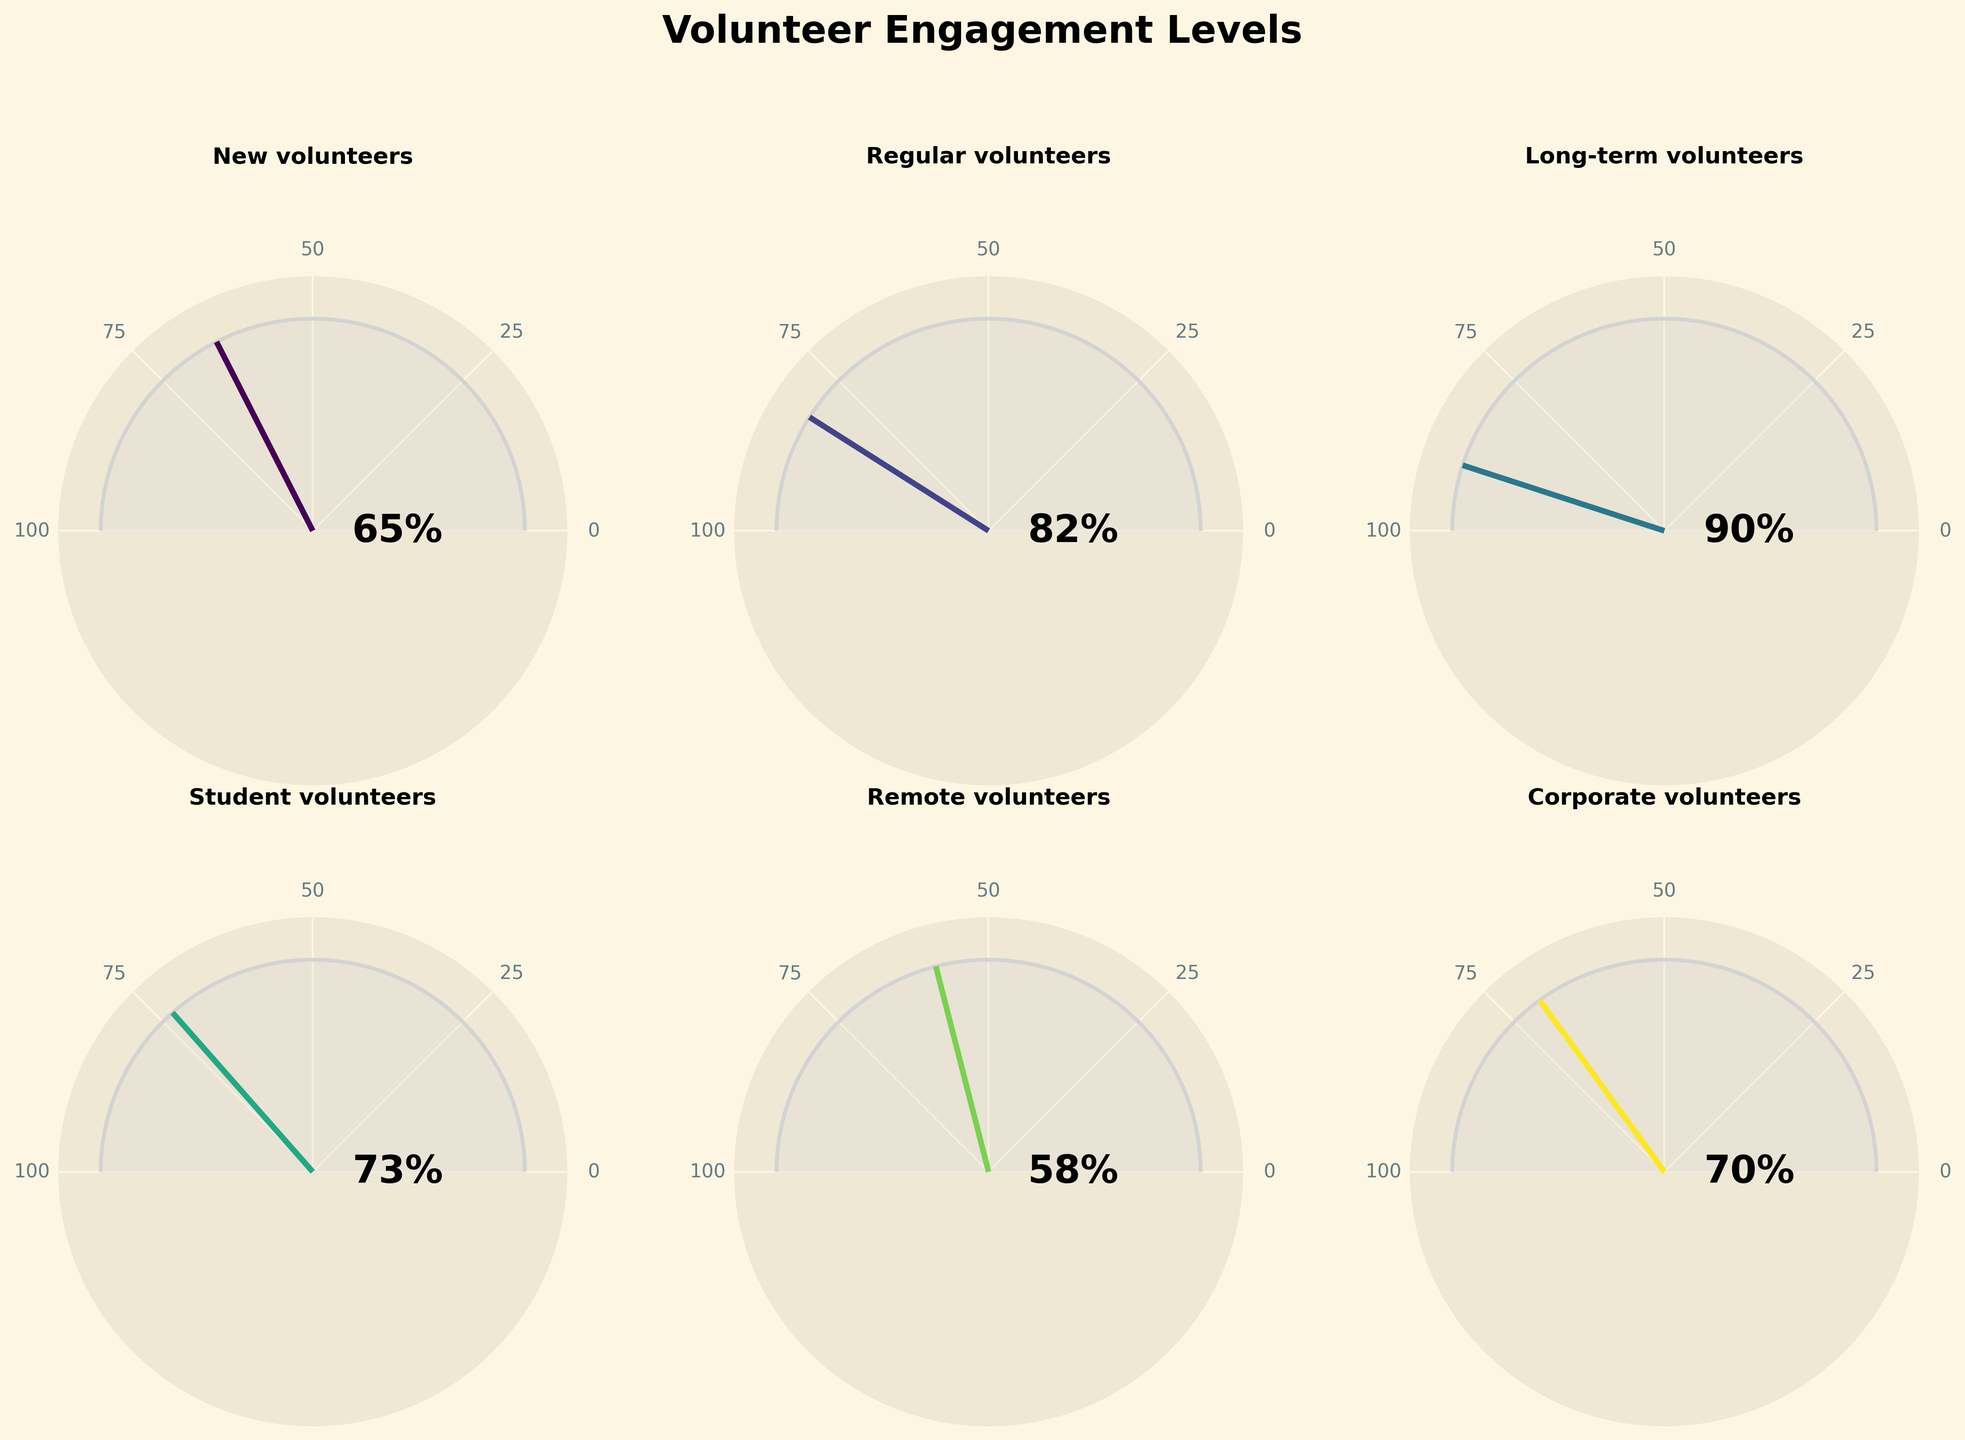What is the engagement level of new volunteers? The engagement level of new volunteers is indicated in the chart next to the label 'New volunteers'. This value can be seen around the gauge pointer and is also noted directly on the chart.
Answer: 65% Which volunteer type has the highest engagement level? By comparing the engagement levels for all volunteer types, the chart shows the highest pointer deflection and percentage for 'Long-term volunteers'.
Answer: Long-term volunteers How many volunteer types have an engagement level greater than 70%? By observing the engagement levels indicated on each gauge chart, count those with values greater than 70%. These are 'Regular volunteers', 'Long-term volunteers', 'Student volunteers', and 'Corporate volunteers'.
Answer: 4 What is the average engagement level among all volunteer types? Add the engagement levels of all volunteer types and divide by the number of types: (65 + 82 + 90 + 73 + 58 + 70) / 6.
Answer: 73 Which two volunteer types have the closest engagement levels and what are their levels? By comparing the engagement levels of each type, 'Student volunteers' (73%) and 'Corporate volunteers' (70%) have the closest levels.
Answer: Student volunteers (73%) and Corporate volunteers (70%) What is the difference in engagement levels between 'Remote volunteers' and 'Corporate volunteers'? Subtract the engagement level of 'Remote volunteers' from that of 'Corporate volunteers': 70 - 58.
Answer: 12 Which volunteer type has the lowest engagement level and what is it? Identify the volunteer type with the smallest pointer deflection and percentage, which is 'Remote volunteers'.
Answer: Remote volunteers (58%) What percentage of volunteer types have engagement levels less than 75%? Count volunteer types with engagement levels less than 75%, then divide by total volunteer types and multiply by 100 to get the percentage: 3/6 * 100.
Answer: 50% Are there any volunteer types with an engagement level exactly at the midpoint (50%)? Examine the gauge charts and engagement values to see if any of them are exactly at 50%. None reach this midpoint.
Answer: No Which volunteer types exceed the average engagement level of all volunteer types? Calculate the average engagement level (73%), then identify those exceeding this value: 'Regular volunteers' (82%) and 'Long-term volunteers' (90%).
Answer: Regular and Long-term volunteers 